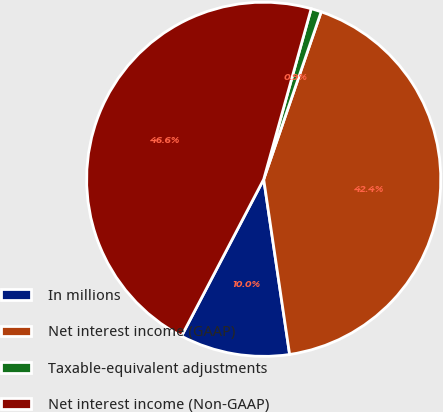Convert chart. <chart><loc_0><loc_0><loc_500><loc_500><pie_chart><fcel>In millions<fcel>Net interest income (GAAP)<fcel>Taxable-equivalent adjustments<fcel>Net interest income (Non-GAAP)<nl><fcel>10.02%<fcel>42.4%<fcel>0.94%<fcel>46.64%<nl></chart> 